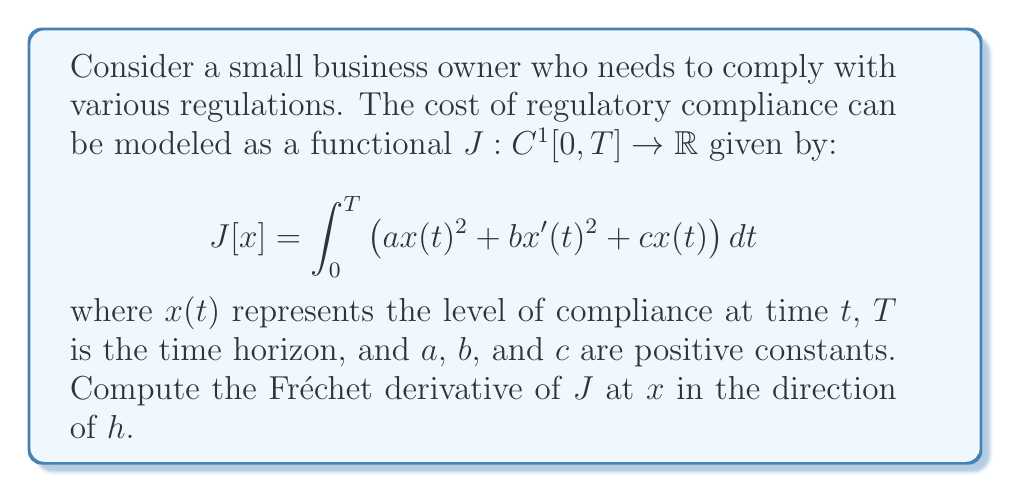Solve this math problem. To compute the Fréchet derivative, we follow these steps:

1) The Fréchet derivative of $J$ at $x$ in the direction of $h$ is defined as:

   $$DJ[x](h) = \lim_{\epsilon \to 0} \frac{J[x + \epsilon h] - J[x]}{\epsilon}$$

2) Let's expand $J[x + \epsilon h]$:

   $$J[x + \epsilon h] = \int_0^T \left(a(x(t) + \epsilon h(t))^2 + b(x'(t) + \epsilon h'(t))^2 + c(x(t) + \epsilon h(t))\right) dt$$

3) Expand the squared terms:

   $$J[x + \epsilon h] = \int_0^T \left(ax(t)^2 + 2a\epsilon x(t)h(t) + a\epsilon^2h(t)^2 + bx'(t)^2 + 2b\epsilon x'(t)h'(t) + b\epsilon^2h'(t)^2 + cx(t) + c\epsilon h(t)\right) dt$$

4) Subtract $J[x]$ and divide by $\epsilon$:

   $$\frac{J[x + \epsilon h] - J[x]}{\epsilon} = \int_0^T \left(2ax(t)h(t) + \epsilon ah(t)^2 + 2bx'(t)h'(t) + \epsilon bh'(t)^2 + ch(t)\right) dt$$

5) Take the limit as $\epsilon \to 0$:

   $$DJ[x](h) = \int_0^T \left(2ax(t)h(t) + 2bx'(t)h'(t) + ch(t)\right) dt$$

6) We can simplify this further by integrating by parts the term with $h'(t)$:

   $$\int_0^T 2bx'(t)h'(t) dt = 2bx(t)h(t)\Big|_0^T - \int_0^T 2bx''(t)h(t) dt$$

7) Assuming $h(0) = h(T) = 0$ (which is typical for variations in calculus of variations), we get:

   $$DJ[x](h) = \int_0^T \left((2ax(t) - 2bx''(t) + c)h(t)\right) dt$$

This is the Fréchet derivative of $J$ at $x$ in the direction of $h$.
Answer: $DJ[x](h) = \int_0^T (2ax(t) - 2bx''(t) + c)h(t) dt$ 